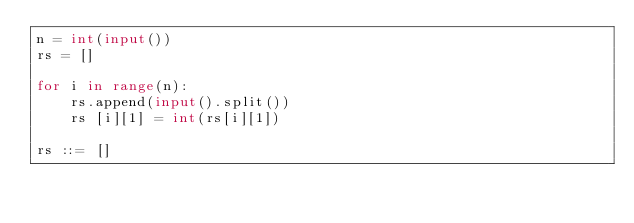<code> <loc_0><loc_0><loc_500><loc_500><_Python_>n = int(input())
rs = []

for i in range(n):
  	rs.append(input().split())
    rs [i][1] = int(rs[i][1])
                    
rs ::= []</code> 